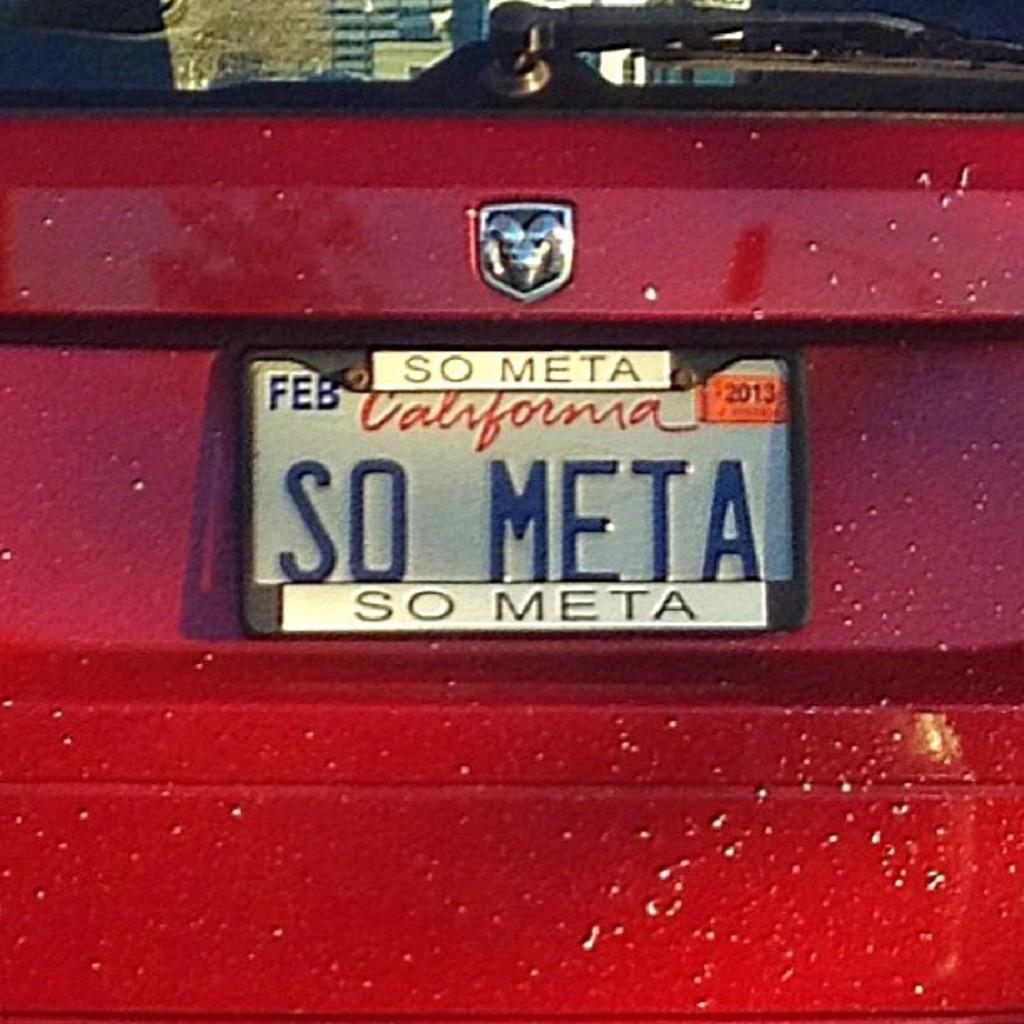Provide a one-sentence caption for the provided image. A car's license plate is so meta, both on the frame and on the plate itself. 